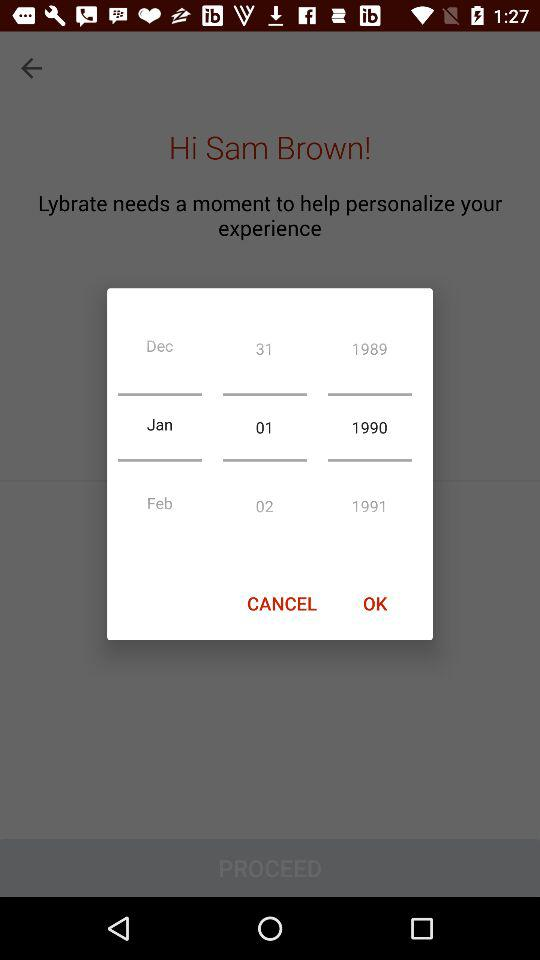What is the name of the user? The user name is "Sam Brown". 